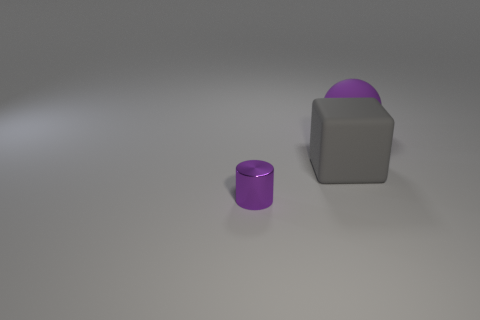Is the color of the tiny shiny thing the same as the large sphere?
Ensure brevity in your answer.  Yes. What is the purple thing that is behind the small cylinder made of?
Keep it short and to the point. Rubber. What number of big things are either purple cubes or gray things?
Ensure brevity in your answer.  1. There is a sphere that is the same color as the tiny metal cylinder; what material is it?
Offer a very short reply. Rubber. Are there any large purple balls that have the same material as the big cube?
Make the answer very short. Yes. There is a purple thing that is right of the cylinder; does it have the same size as the tiny cylinder?
Give a very brief answer. No. Are there any gray rubber blocks to the right of the purple object left of the rubber thing that is on the right side of the large gray thing?
Provide a succinct answer. Yes. What number of shiny things are either gray objects or red blocks?
Provide a succinct answer. 0. How many other things are the same shape as the metallic thing?
Provide a short and direct response. 0. Are there more big matte objects than small cyan cubes?
Your response must be concise. Yes. 